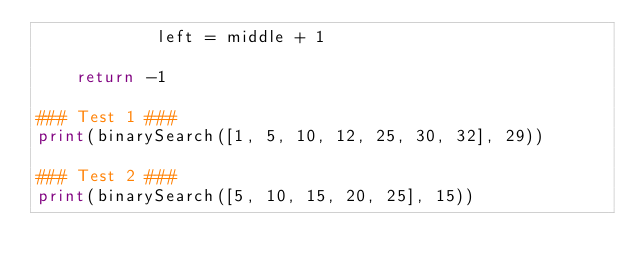<code> <loc_0><loc_0><loc_500><loc_500><_Python_>            left = middle + 1

    return -1

### Test 1 ###
print(binarySearch([1, 5, 10, 12, 25, 30, 32], 29))

### Test 2 ###
print(binarySearch([5, 10, 15, 20, 25], 15))</code> 